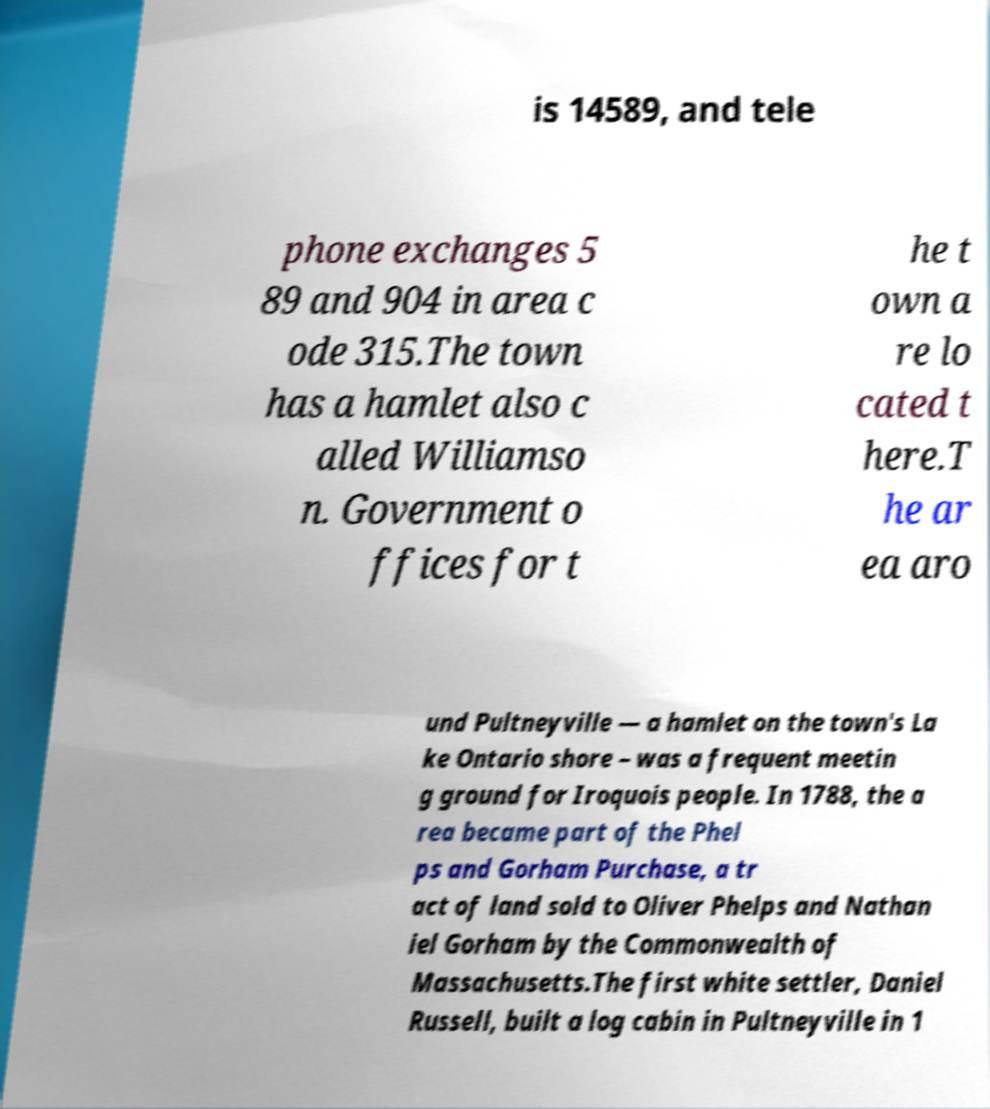Could you extract and type out the text from this image? is 14589, and tele phone exchanges 5 89 and 904 in area c ode 315.The town has a hamlet also c alled Williamso n. Government o ffices for t he t own a re lo cated t here.T he ar ea aro und Pultneyville — a hamlet on the town's La ke Ontario shore – was a frequent meetin g ground for Iroquois people. In 1788, the a rea became part of the Phel ps and Gorham Purchase, a tr act of land sold to Oliver Phelps and Nathan iel Gorham by the Commonwealth of Massachusetts.The first white settler, Daniel Russell, built a log cabin in Pultneyville in 1 